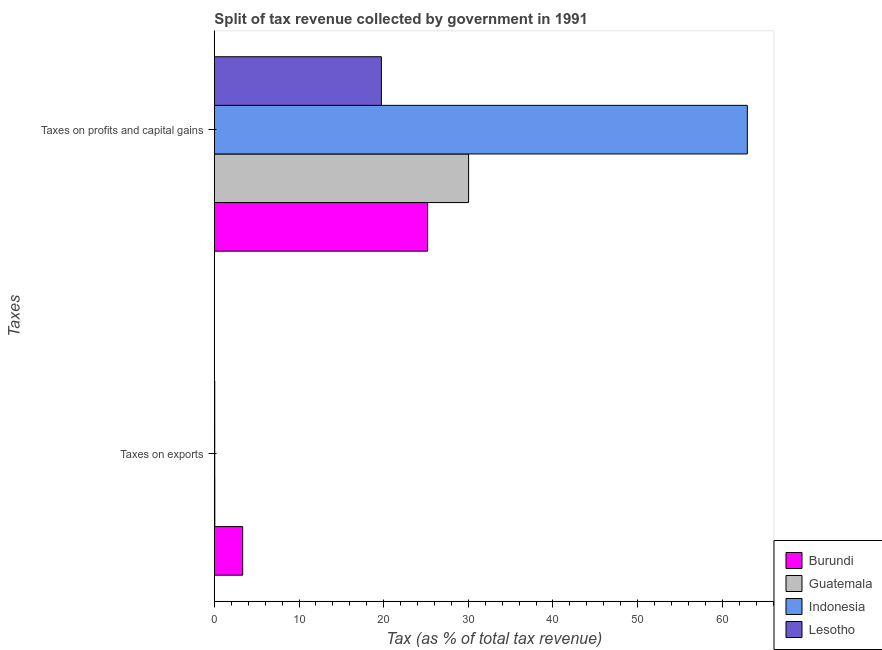Are the number of bars on each tick of the Y-axis equal?
Your response must be concise. Yes. How many bars are there on the 2nd tick from the bottom?
Offer a terse response. 4. What is the label of the 2nd group of bars from the top?
Provide a short and direct response. Taxes on exports. What is the percentage of revenue obtained from taxes on exports in Burundi?
Offer a terse response. 3.35. Across all countries, what is the maximum percentage of revenue obtained from taxes on exports?
Offer a terse response. 3.35. Across all countries, what is the minimum percentage of revenue obtained from taxes on profits and capital gains?
Your answer should be compact. 19.74. In which country was the percentage of revenue obtained from taxes on exports maximum?
Your answer should be very brief. Burundi. In which country was the percentage of revenue obtained from taxes on profits and capital gains minimum?
Provide a short and direct response. Lesotho. What is the total percentage of revenue obtained from taxes on profits and capital gains in the graph?
Your answer should be compact. 137.94. What is the difference between the percentage of revenue obtained from taxes on profits and capital gains in Indonesia and that in Guatemala?
Keep it short and to the point. 32.93. What is the difference between the percentage of revenue obtained from taxes on exports in Burundi and the percentage of revenue obtained from taxes on profits and capital gains in Lesotho?
Keep it short and to the point. -16.39. What is the average percentage of revenue obtained from taxes on profits and capital gains per country?
Make the answer very short. 34.48. What is the difference between the percentage of revenue obtained from taxes on profits and capital gains and percentage of revenue obtained from taxes on exports in Guatemala?
Make the answer very short. 29.98. What is the ratio of the percentage of revenue obtained from taxes on exports in Indonesia to that in Lesotho?
Your answer should be very brief. 1.01. What does the 4th bar from the top in Taxes on profits and capital gains represents?
Offer a terse response. Burundi. What does the 1st bar from the bottom in Taxes on profits and capital gains represents?
Provide a succinct answer. Burundi. Are the values on the major ticks of X-axis written in scientific E-notation?
Provide a short and direct response. No. Does the graph contain any zero values?
Ensure brevity in your answer.  No. Does the graph contain grids?
Offer a terse response. No. How many legend labels are there?
Your answer should be very brief. 4. What is the title of the graph?
Your response must be concise. Split of tax revenue collected by government in 1991. Does "Romania" appear as one of the legend labels in the graph?
Ensure brevity in your answer.  No. What is the label or title of the X-axis?
Keep it short and to the point. Tax (as % of total tax revenue). What is the label or title of the Y-axis?
Give a very brief answer. Taxes. What is the Tax (as % of total tax revenue) in Burundi in Taxes on exports?
Keep it short and to the point. 3.35. What is the Tax (as % of total tax revenue) in Guatemala in Taxes on exports?
Provide a short and direct response. 0.06. What is the Tax (as % of total tax revenue) in Indonesia in Taxes on exports?
Your response must be concise. 0.05. What is the Tax (as % of total tax revenue) of Lesotho in Taxes on exports?
Provide a succinct answer. 0.05. What is the Tax (as % of total tax revenue) of Burundi in Taxes on profits and capital gains?
Ensure brevity in your answer.  25.2. What is the Tax (as % of total tax revenue) in Guatemala in Taxes on profits and capital gains?
Your response must be concise. 30.04. What is the Tax (as % of total tax revenue) of Indonesia in Taxes on profits and capital gains?
Ensure brevity in your answer.  62.97. What is the Tax (as % of total tax revenue) in Lesotho in Taxes on profits and capital gains?
Keep it short and to the point. 19.74. Across all Taxes, what is the maximum Tax (as % of total tax revenue) in Burundi?
Keep it short and to the point. 25.2. Across all Taxes, what is the maximum Tax (as % of total tax revenue) of Guatemala?
Ensure brevity in your answer.  30.04. Across all Taxes, what is the maximum Tax (as % of total tax revenue) in Indonesia?
Provide a succinct answer. 62.97. Across all Taxes, what is the maximum Tax (as % of total tax revenue) in Lesotho?
Ensure brevity in your answer.  19.74. Across all Taxes, what is the minimum Tax (as % of total tax revenue) of Burundi?
Offer a terse response. 3.35. Across all Taxes, what is the minimum Tax (as % of total tax revenue) of Guatemala?
Your response must be concise. 0.06. Across all Taxes, what is the minimum Tax (as % of total tax revenue) in Indonesia?
Your answer should be compact. 0.05. Across all Taxes, what is the minimum Tax (as % of total tax revenue) in Lesotho?
Give a very brief answer. 0.05. What is the total Tax (as % of total tax revenue) of Burundi in the graph?
Offer a terse response. 28.54. What is the total Tax (as % of total tax revenue) in Guatemala in the graph?
Make the answer very short. 30.09. What is the total Tax (as % of total tax revenue) of Indonesia in the graph?
Your response must be concise. 63.02. What is the total Tax (as % of total tax revenue) in Lesotho in the graph?
Offer a very short reply. 19.78. What is the difference between the Tax (as % of total tax revenue) in Burundi in Taxes on exports and that in Taxes on profits and capital gains?
Provide a succinct answer. -21.85. What is the difference between the Tax (as % of total tax revenue) in Guatemala in Taxes on exports and that in Taxes on profits and capital gains?
Offer a very short reply. -29.98. What is the difference between the Tax (as % of total tax revenue) of Indonesia in Taxes on exports and that in Taxes on profits and capital gains?
Keep it short and to the point. -62.92. What is the difference between the Tax (as % of total tax revenue) in Lesotho in Taxes on exports and that in Taxes on profits and capital gains?
Keep it short and to the point. -19.69. What is the difference between the Tax (as % of total tax revenue) of Burundi in Taxes on exports and the Tax (as % of total tax revenue) of Guatemala in Taxes on profits and capital gains?
Ensure brevity in your answer.  -26.69. What is the difference between the Tax (as % of total tax revenue) of Burundi in Taxes on exports and the Tax (as % of total tax revenue) of Indonesia in Taxes on profits and capital gains?
Provide a short and direct response. -59.62. What is the difference between the Tax (as % of total tax revenue) in Burundi in Taxes on exports and the Tax (as % of total tax revenue) in Lesotho in Taxes on profits and capital gains?
Provide a succinct answer. -16.39. What is the difference between the Tax (as % of total tax revenue) of Guatemala in Taxes on exports and the Tax (as % of total tax revenue) of Indonesia in Taxes on profits and capital gains?
Ensure brevity in your answer.  -62.91. What is the difference between the Tax (as % of total tax revenue) in Guatemala in Taxes on exports and the Tax (as % of total tax revenue) in Lesotho in Taxes on profits and capital gains?
Provide a succinct answer. -19.68. What is the difference between the Tax (as % of total tax revenue) of Indonesia in Taxes on exports and the Tax (as % of total tax revenue) of Lesotho in Taxes on profits and capital gains?
Your answer should be compact. -19.69. What is the average Tax (as % of total tax revenue) in Burundi per Taxes?
Give a very brief answer. 14.27. What is the average Tax (as % of total tax revenue) of Guatemala per Taxes?
Keep it short and to the point. 15.05. What is the average Tax (as % of total tax revenue) in Indonesia per Taxes?
Provide a short and direct response. 31.51. What is the average Tax (as % of total tax revenue) of Lesotho per Taxes?
Provide a short and direct response. 9.89. What is the difference between the Tax (as % of total tax revenue) in Burundi and Tax (as % of total tax revenue) in Guatemala in Taxes on exports?
Your answer should be compact. 3.29. What is the difference between the Tax (as % of total tax revenue) in Burundi and Tax (as % of total tax revenue) in Indonesia in Taxes on exports?
Give a very brief answer. 3.3. What is the difference between the Tax (as % of total tax revenue) in Burundi and Tax (as % of total tax revenue) in Lesotho in Taxes on exports?
Provide a succinct answer. 3.3. What is the difference between the Tax (as % of total tax revenue) of Guatemala and Tax (as % of total tax revenue) of Indonesia in Taxes on exports?
Your answer should be very brief. 0.01. What is the difference between the Tax (as % of total tax revenue) in Guatemala and Tax (as % of total tax revenue) in Lesotho in Taxes on exports?
Offer a terse response. 0.01. What is the difference between the Tax (as % of total tax revenue) in Indonesia and Tax (as % of total tax revenue) in Lesotho in Taxes on exports?
Your answer should be very brief. 0. What is the difference between the Tax (as % of total tax revenue) of Burundi and Tax (as % of total tax revenue) of Guatemala in Taxes on profits and capital gains?
Make the answer very short. -4.84. What is the difference between the Tax (as % of total tax revenue) in Burundi and Tax (as % of total tax revenue) in Indonesia in Taxes on profits and capital gains?
Your answer should be very brief. -37.77. What is the difference between the Tax (as % of total tax revenue) of Burundi and Tax (as % of total tax revenue) of Lesotho in Taxes on profits and capital gains?
Provide a succinct answer. 5.46. What is the difference between the Tax (as % of total tax revenue) in Guatemala and Tax (as % of total tax revenue) in Indonesia in Taxes on profits and capital gains?
Your answer should be compact. -32.93. What is the difference between the Tax (as % of total tax revenue) in Indonesia and Tax (as % of total tax revenue) in Lesotho in Taxes on profits and capital gains?
Provide a succinct answer. 43.23. What is the ratio of the Tax (as % of total tax revenue) in Burundi in Taxes on exports to that in Taxes on profits and capital gains?
Offer a very short reply. 0.13. What is the ratio of the Tax (as % of total tax revenue) in Guatemala in Taxes on exports to that in Taxes on profits and capital gains?
Your answer should be very brief. 0. What is the ratio of the Tax (as % of total tax revenue) in Indonesia in Taxes on exports to that in Taxes on profits and capital gains?
Provide a short and direct response. 0. What is the ratio of the Tax (as % of total tax revenue) of Lesotho in Taxes on exports to that in Taxes on profits and capital gains?
Your answer should be very brief. 0. What is the difference between the highest and the second highest Tax (as % of total tax revenue) in Burundi?
Provide a short and direct response. 21.85. What is the difference between the highest and the second highest Tax (as % of total tax revenue) in Guatemala?
Your response must be concise. 29.98. What is the difference between the highest and the second highest Tax (as % of total tax revenue) in Indonesia?
Offer a terse response. 62.92. What is the difference between the highest and the second highest Tax (as % of total tax revenue) of Lesotho?
Your answer should be very brief. 19.69. What is the difference between the highest and the lowest Tax (as % of total tax revenue) of Burundi?
Your answer should be compact. 21.85. What is the difference between the highest and the lowest Tax (as % of total tax revenue) in Guatemala?
Give a very brief answer. 29.98. What is the difference between the highest and the lowest Tax (as % of total tax revenue) in Indonesia?
Your answer should be very brief. 62.92. What is the difference between the highest and the lowest Tax (as % of total tax revenue) in Lesotho?
Give a very brief answer. 19.69. 